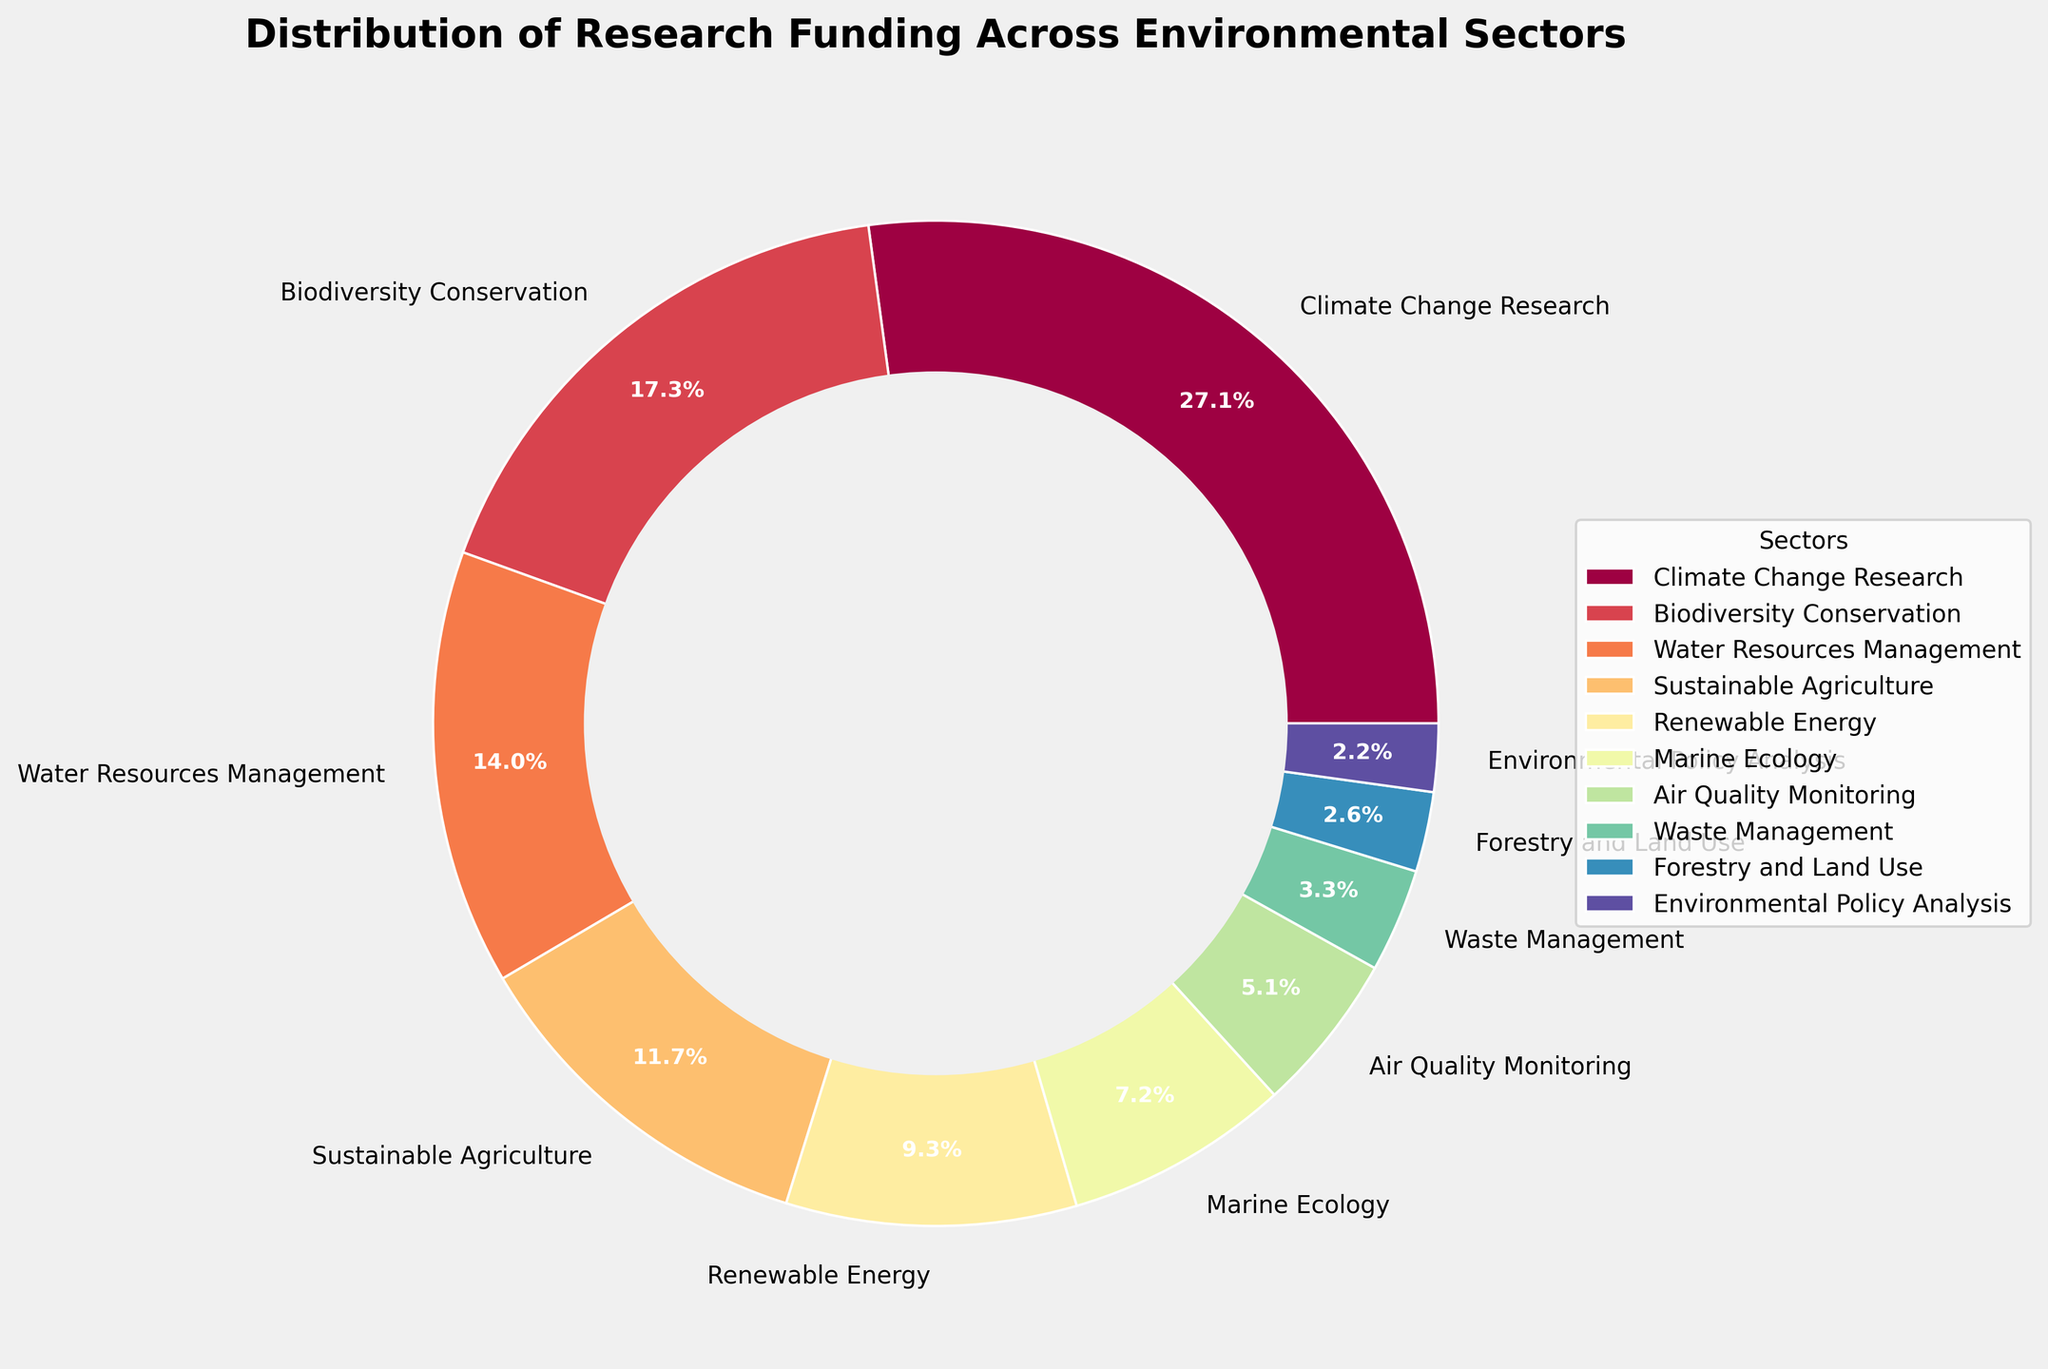what sector receives the highest funding percentage? The pie chart shows the funding percentage for each sector; the largest wedge correlates to Climate Change Research with 28.5%.
Answer: Climate Change Research compare the funding percentages for Marine Ecology and Air Quality Monitoring The pie chart labels Marine Ecology at 7.6% and Air Quality Monitoring at 5.4%. Subtracting 5.4 from 7.6, you get 2.2
Answer: Marine Ecology receives 2.2% more funding what is the combined funding percentage for Sustainable Agriculture, Renewable Energy, and Waste Management? Add the funding percentages for Sustainable Agriculture (12.3%), Renewable Energy (9.8%), and Waste Management (3.5%). The sum is 12.3 + 9.8 + 3.5 = 25.6
Answer: 25.6% Which sector has a funding percentage closest to 10%? The funding percentages are listed for each sector, the closest number to 10% is Renewable Energy, which is 9.8%.
Answer: Renewable Energy How does the funding for Water Resources Management compare to Forestry and Land Use? The pie chart shows 14.7% for Water Resources Management and 2.7% for Forestry and Land Use. Subtract 2.7 from 14.7, you get 12.
Answer: Water Resources Management receives 12% more How many sectors have funding percentages below 10%? From the pie chart, count the sectors with percentages lower than 10: Renewable Energy (9.8%), Marine Ecology (7.6%), Air Quality Monitoring (5.4%), Waste Management (3.5%), Forestry and Land Use (2.7%), Environmental Policy Analysis (2.3%).
Answer: 6 sectors What is the visual characteristic of the sector with the lowest funding? In the pie chart, Environmental Policy Analysis has the smallest wedge, indicating it has the lowest funding percentage at 2.3%.
Answer: Environmental Policy Analysis What is the difference between the funding percentages of the highest and lowest funded sectors? The highest funded sector is Climate Change Research at 28.5%, and the lowest is Environmental Policy Analysis at 2.3%. The difference is 28.5 - 2.3 = 26.2.
Answer: 26.2% If marine ecology received a 2% increase in funding, what would its total funding percentage be, and would it affect its position relative to other sectors? Currently, Marine Ecology is at 7.6%. An increase of 2% would make it 7.6 + 2 = 9.6%. After the increase, Marine Ecology would have a higher percentage than Air Quality Monitoring but still lower than Renewable Energy.
Answer: 9.6%; no change in position relative to other sectors 